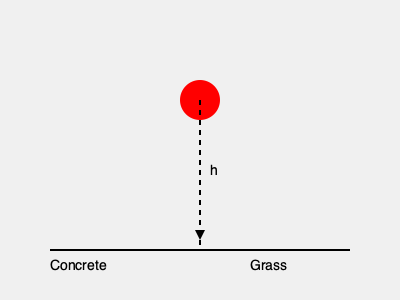A cricket ball of mass $m = 0.16$ kg is dropped from a height $h = 1.5$ m onto two different surfaces: concrete and grass. The coefficient of restitution for the ball on concrete is $e_c = 0.7$, while on grass it's $e_g = 0.4$. Calculate the maximum impact force $F_{max}$ experienced by the ball on each surface, assuming the collision time with concrete is $t_c = 0.005$ s and with grass is $t_g = 0.02$ s. Which surface results in a greater impact force, and by what factor? Let's approach this step-by-step:

1) First, calculate the velocity of the ball just before impact using the equation:
   $v = \sqrt{2gh}$, where $g = 9.81$ m/s²
   $v = \sqrt{2 \times 9.81 \times 1.5} = 5.42$ m/s

2) The coefficient of restitution $e$ is given by $e = \frac{v_f}{v_i}$, where $v_f$ is the final (rebound) velocity and $v_i$ is the initial velocity.

3) For concrete:
   $v_f = e_c \times v_i = 0.7 \times 5.42 = 3.79$ m/s
   Change in velocity: $\Delta v_c = v_i + v_f = 5.42 + 3.79 = 9.21$ m/s

4) For grass:
   $v_f = e_g \times v_i = 0.4 \times 5.42 = 2.17$ m/s
   Change in velocity: $\Delta v_g = v_i + v_f = 5.42 + 2.17 = 7.59$ m/s

5) Use the impulse-momentum theorem: $F_{avg} = \frac{m\Delta v}{t}$

6) For concrete:
   $F_{max_c} = \frac{0.16 \times 9.21}{0.005} = 294.72$ N

7) For grass:
   $F_{max_g} = \frac{0.16 \times 7.59}{0.02} = 60.72$ N

8) The ratio of impact forces:
   $\frac{F_{max_c}}{F_{max_g}} = \frac{294.72}{60.72} \approx 4.85$

Therefore, the impact force on concrete is about 4.85 times greater than on grass.
Answer: $F_{max_c} = 294.72$ N, $F_{max_g} = 60.72$ N; Concrete, 4.85 times greater 